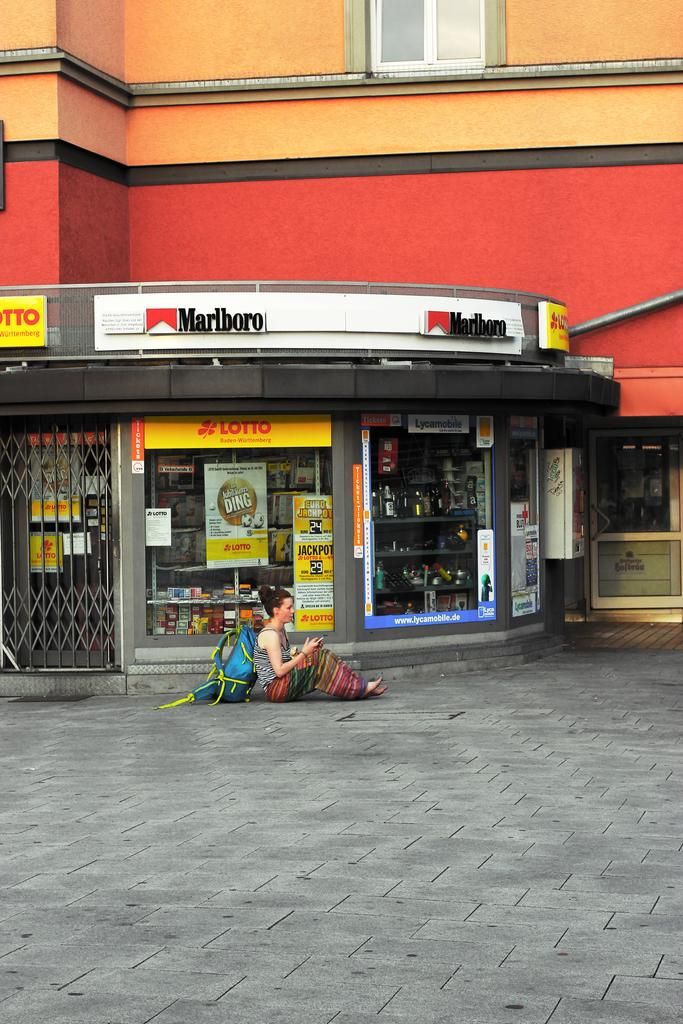<image>
Describe the image concisely. A store front with a person sitting in front, the store has a Marlboro ad on it. 